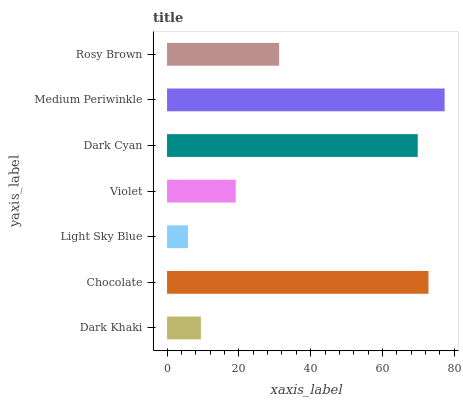Is Light Sky Blue the minimum?
Answer yes or no. Yes. Is Medium Periwinkle the maximum?
Answer yes or no. Yes. Is Chocolate the minimum?
Answer yes or no. No. Is Chocolate the maximum?
Answer yes or no. No. Is Chocolate greater than Dark Khaki?
Answer yes or no. Yes. Is Dark Khaki less than Chocolate?
Answer yes or no. Yes. Is Dark Khaki greater than Chocolate?
Answer yes or no. No. Is Chocolate less than Dark Khaki?
Answer yes or no. No. Is Rosy Brown the high median?
Answer yes or no. Yes. Is Rosy Brown the low median?
Answer yes or no. Yes. Is Dark Cyan the high median?
Answer yes or no. No. Is Light Sky Blue the low median?
Answer yes or no. No. 